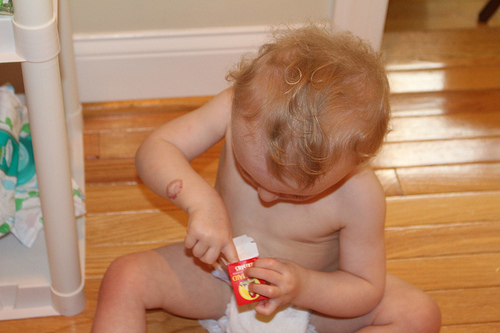<image>
Can you confirm if the baby is on the floor? Yes. Looking at the image, I can see the baby is positioned on top of the floor, with the floor providing support. 